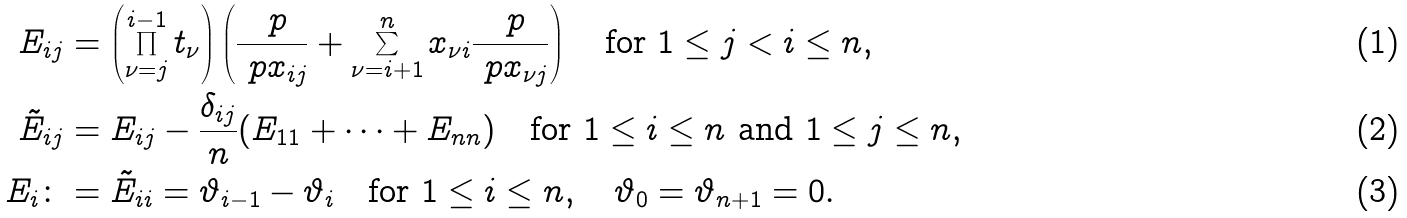<formula> <loc_0><loc_0><loc_500><loc_500>E _ { i j } & = \left ( \prod _ { \nu = j } ^ { i - 1 } t _ { \nu } \right ) \left ( \frac { \ p } { \ p x _ { i j } } + \sum _ { \nu = i + 1 } ^ { n } x _ { \nu i } \frac { \ p } { \ p x _ { \nu j } } \right ) \quad \text {for } 1 \leq j < i \leq n , \\ \tilde { E } _ { i j } & = E _ { i j } - \frac { \delta _ { i j } } n ( E _ { 1 1 } + \cdots + E _ { n n } ) \quad \text {for } 1 \leq i \leq n \text { and } 1 \leq j \leq n , \\ E _ { i } \colon & = \tilde { E } _ { i i } = \vartheta _ { i - 1 } - \vartheta _ { i } \quad \text {for } 1 \leq i \leq n , \quad \vartheta _ { 0 } = \vartheta _ { n + 1 } = 0 .</formula> 